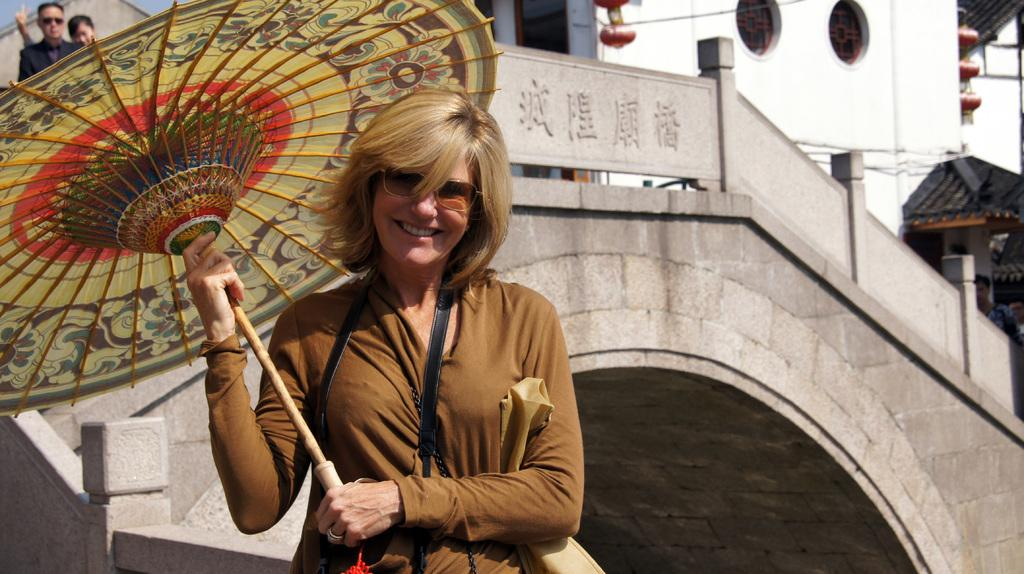Who is present in the image? There is a woman in the image. What is the woman doing in the image? The woman is smiling in the image. What object is the woman holding in the image? The woman is holding an umbrella in the image. What can be seen in the background of the image? There is a building and a couple in the background of the image. Is the woman swimming in the image? No, the woman is not swimming in the image; she is holding an umbrella. 